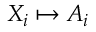<formula> <loc_0><loc_0><loc_500><loc_500>X _ { i } \mapsto A _ { i }</formula> 